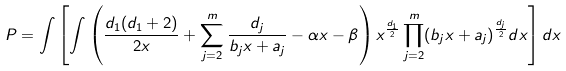Convert formula to latex. <formula><loc_0><loc_0><loc_500><loc_500>P = \int \left [ \int \left ( \frac { d _ { 1 } ( d _ { 1 } + 2 ) } { 2 x } + \sum _ { j = 2 } ^ { m } \frac { d _ { j } } { b _ { j } x + a _ { j } } - \alpha x - \beta \right ) x ^ { \frac { d _ { 1 } } { 2 } } \prod _ { j = 2 } ^ { m } ( b _ { j } x + a _ { j } ) ^ { \frac { d _ { j } } { 2 } } d x \right ] d x</formula> 